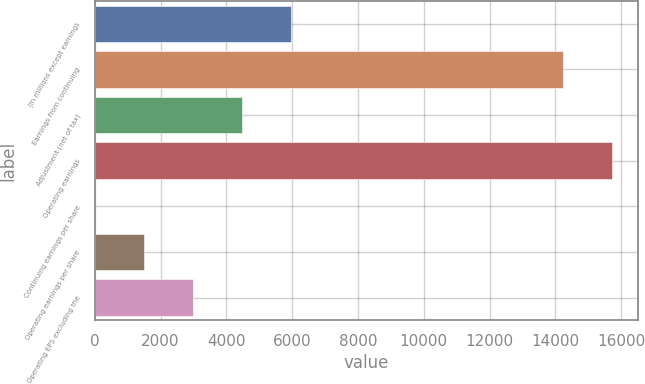Convert chart to OTSL. <chart><loc_0><loc_0><loc_500><loc_500><bar_chart><fcel>(In millions except earnings<fcel>Earnings from continuing<fcel>Adjustment (net of tax)<fcel>Operating earnings<fcel>Continuing earnings per share<fcel>Operating earnings per share<fcel>Operating EPS excluding the<nl><fcel>5966.76<fcel>14227<fcel>4475.38<fcel>15718.4<fcel>1.24<fcel>1492.62<fcel>2984<nl></chart> 